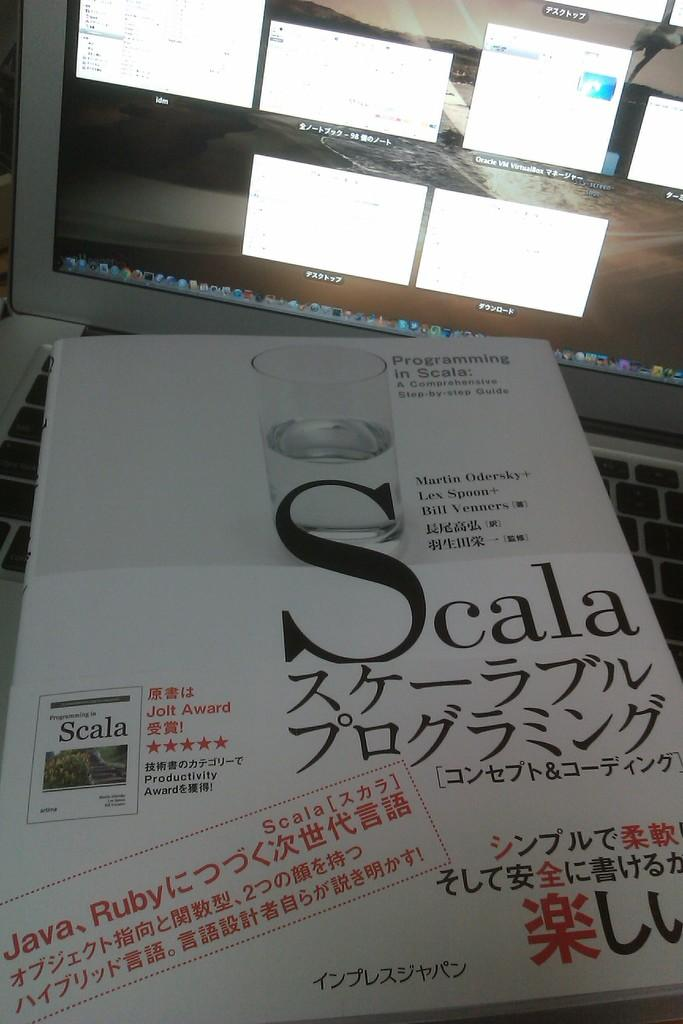<image>
Provide a brief description of the given image. A step-by-step guide to programming with Scala is laying on a keyboard in front of a monitor. 